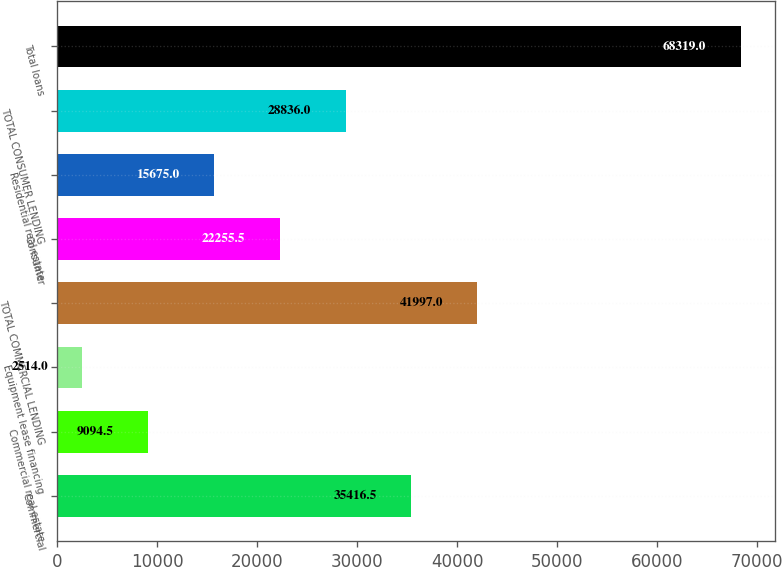<chart> <loc_0><loc_0><loc_500><loc_500><bar_chart><fcel>Commercial<fcel>Commercial real estate<fcel>Equipment lease financing<fcel>TOTAL COMMERCIAL LENDING<fcel>Consumer<fcel>Residential real estate<fcel>TOTAL CONSUMER LENDING<fcel>Total loans<nl><fcel>35416.5<fcel>9094.5<fcel>2514<fcel>41997<fcel>22255.5<fcel>15675<fcel>28836<fcel>68319<nl></chart> 